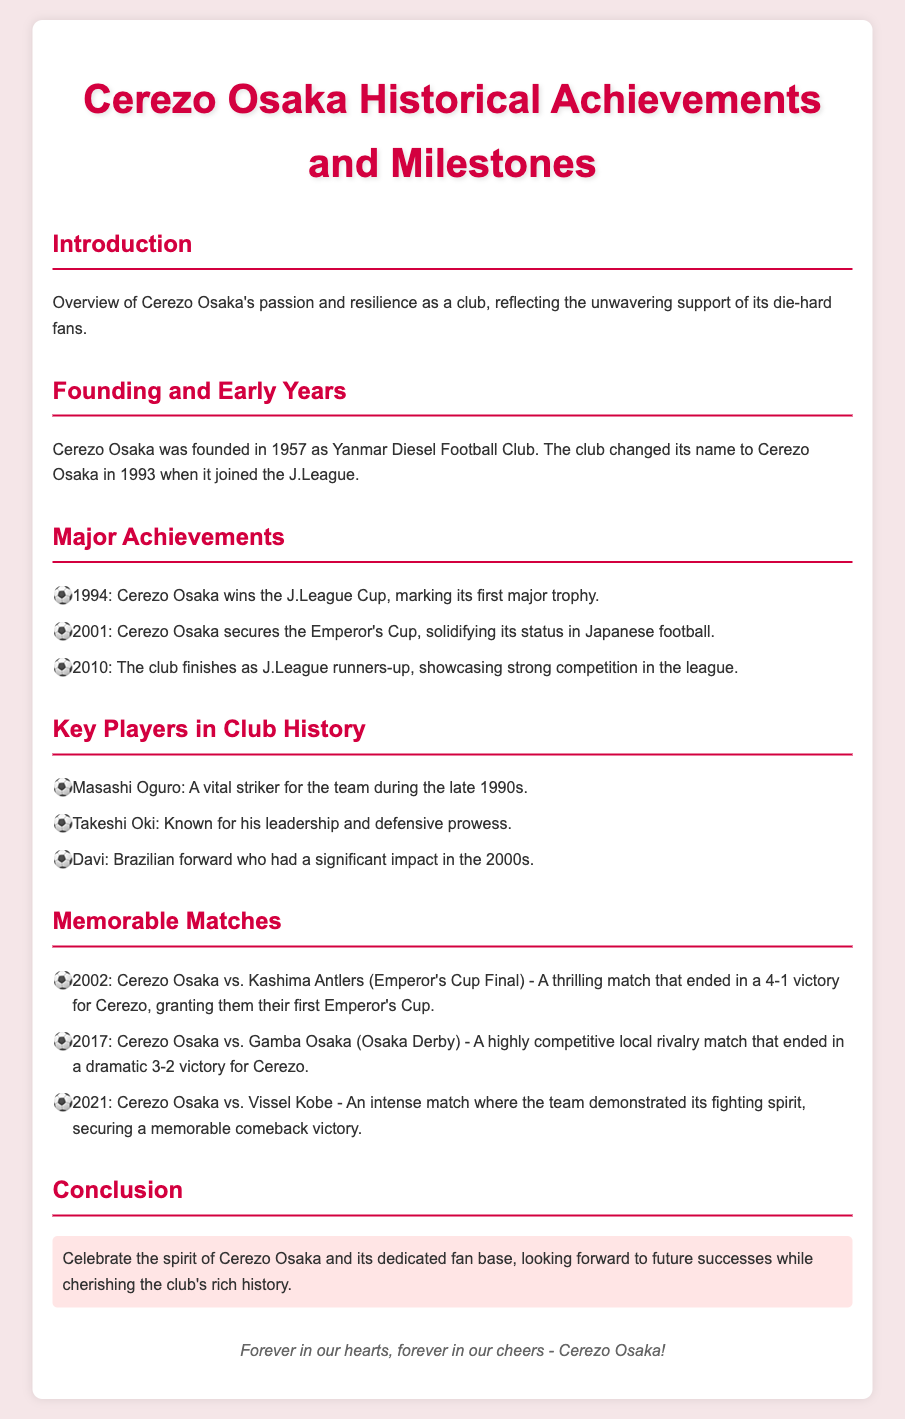What year was Cerezo Osaka founded? The document states that Cerezo Osaka was founded in 1957.
Answer: 1957 What trophy did Cerezo Osaka win in 1994? According to the document, Cerezo Osaka won the J.League Cup in 1994.
Answer: J.League Cup Who was a vital striker for the team during the late 1990s? The document mentions Masashi Oguro as a vital striker during that time.
Answer: Masashi Oguro What was the score in the 2002 Emperor's Cup Final against Kashima Antlers? The document states that the match ended in a 4-1 victory for Cerezo Osaka.
Answer: 4-1 Which player is known for his leadership and defensive prowess? The document identifies Takeshi Oki as known for his leadership and defensive skills.
Answer: Takeshi Oki How many major trophies are listed under Major Achievements? The document lists three major trophies: J.League Cup, Emperor's Cup, and J.League runners-up.
Answer: Three What significant event occurred for Cerezo Osaka in 2010? The document states that Cerezo Osaka finished as J.League runners-up in 2010.
Answer: J.League runners-up What is the overarching theme of the conclusion? The document highlights celebrating the spirit of Cerezo Osaka and looking forward to future successes.
Answer: Celebrate the spirit In what year did Cerezo Osaka secure a memorable comeback victory against Vissel Kobe? According to the document, the comeback victory against Vissel Kobe occurred in 2021.
Answer: 2021 